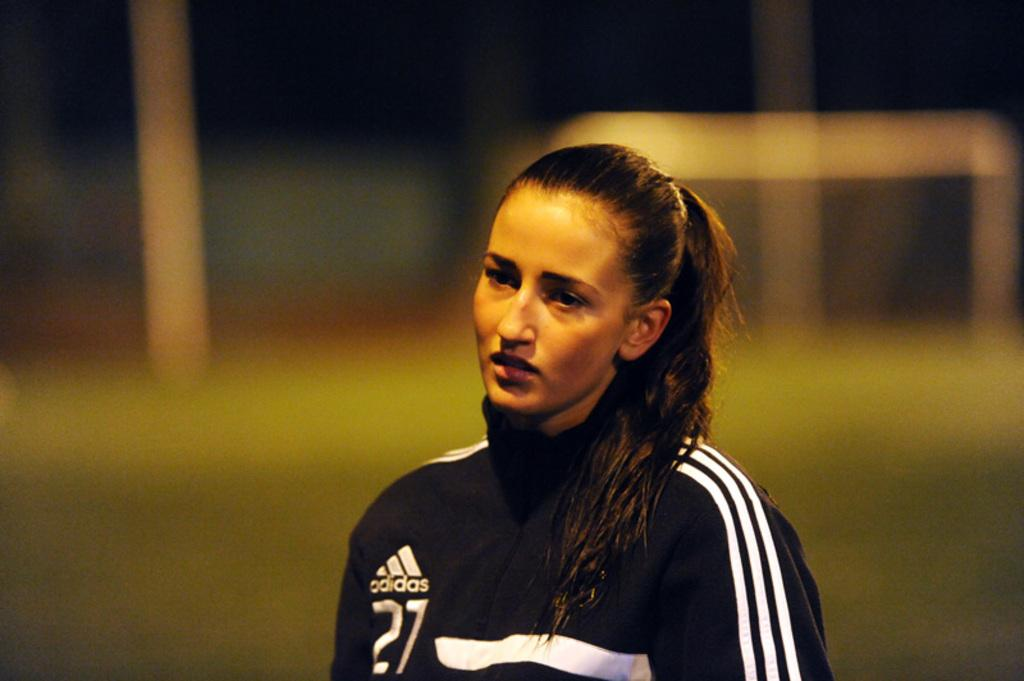<image>
Share a concise interpretation of the image provided. a person that has the number 27 on their outfit 